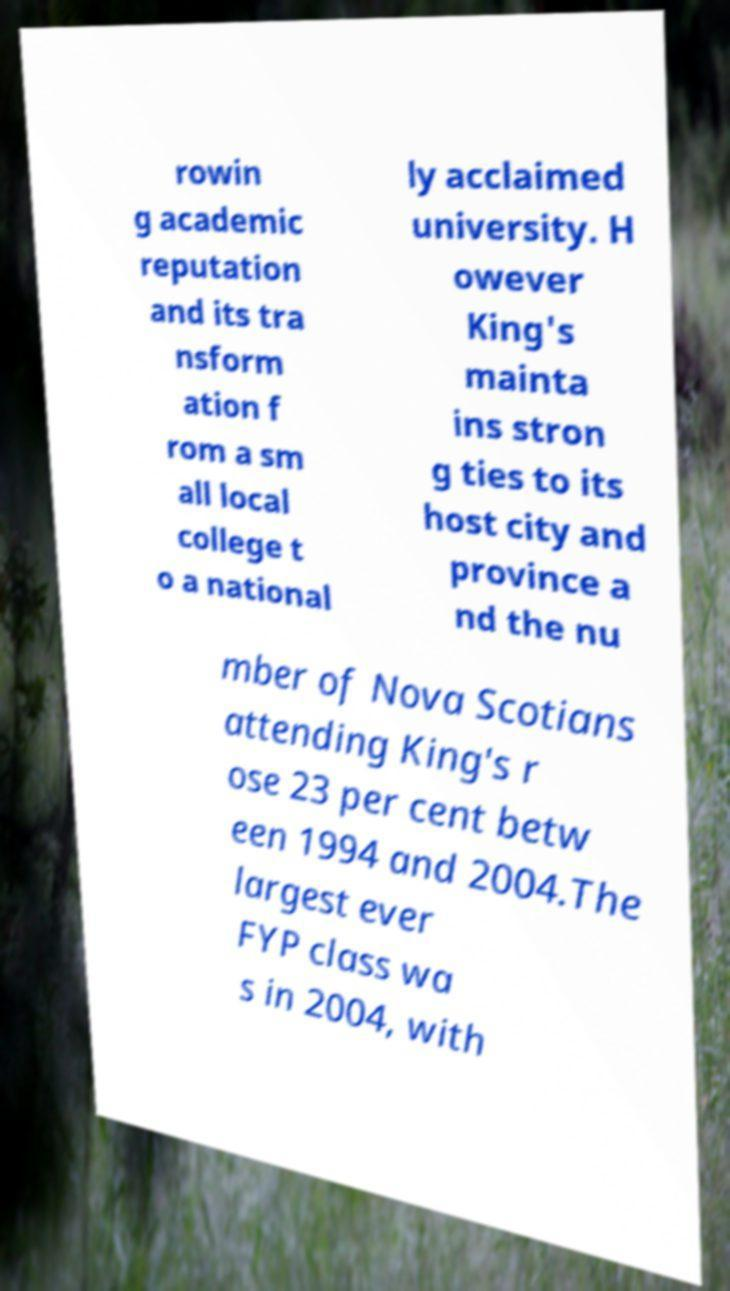There's text embedded in this image that I need extracted. Can you transcribe it verbatim? rowin g academic reputation and its tra nsform ation f rom a sm all local college t o a national ly acclaimed university. H owever King's mainta ins stron g ties to its host city and province a nd the nu mber of Nova Scotians attending King's r ose 23 per cent betw een 1994 and 2004.The largest ever FYP class wa s in 2004, with 